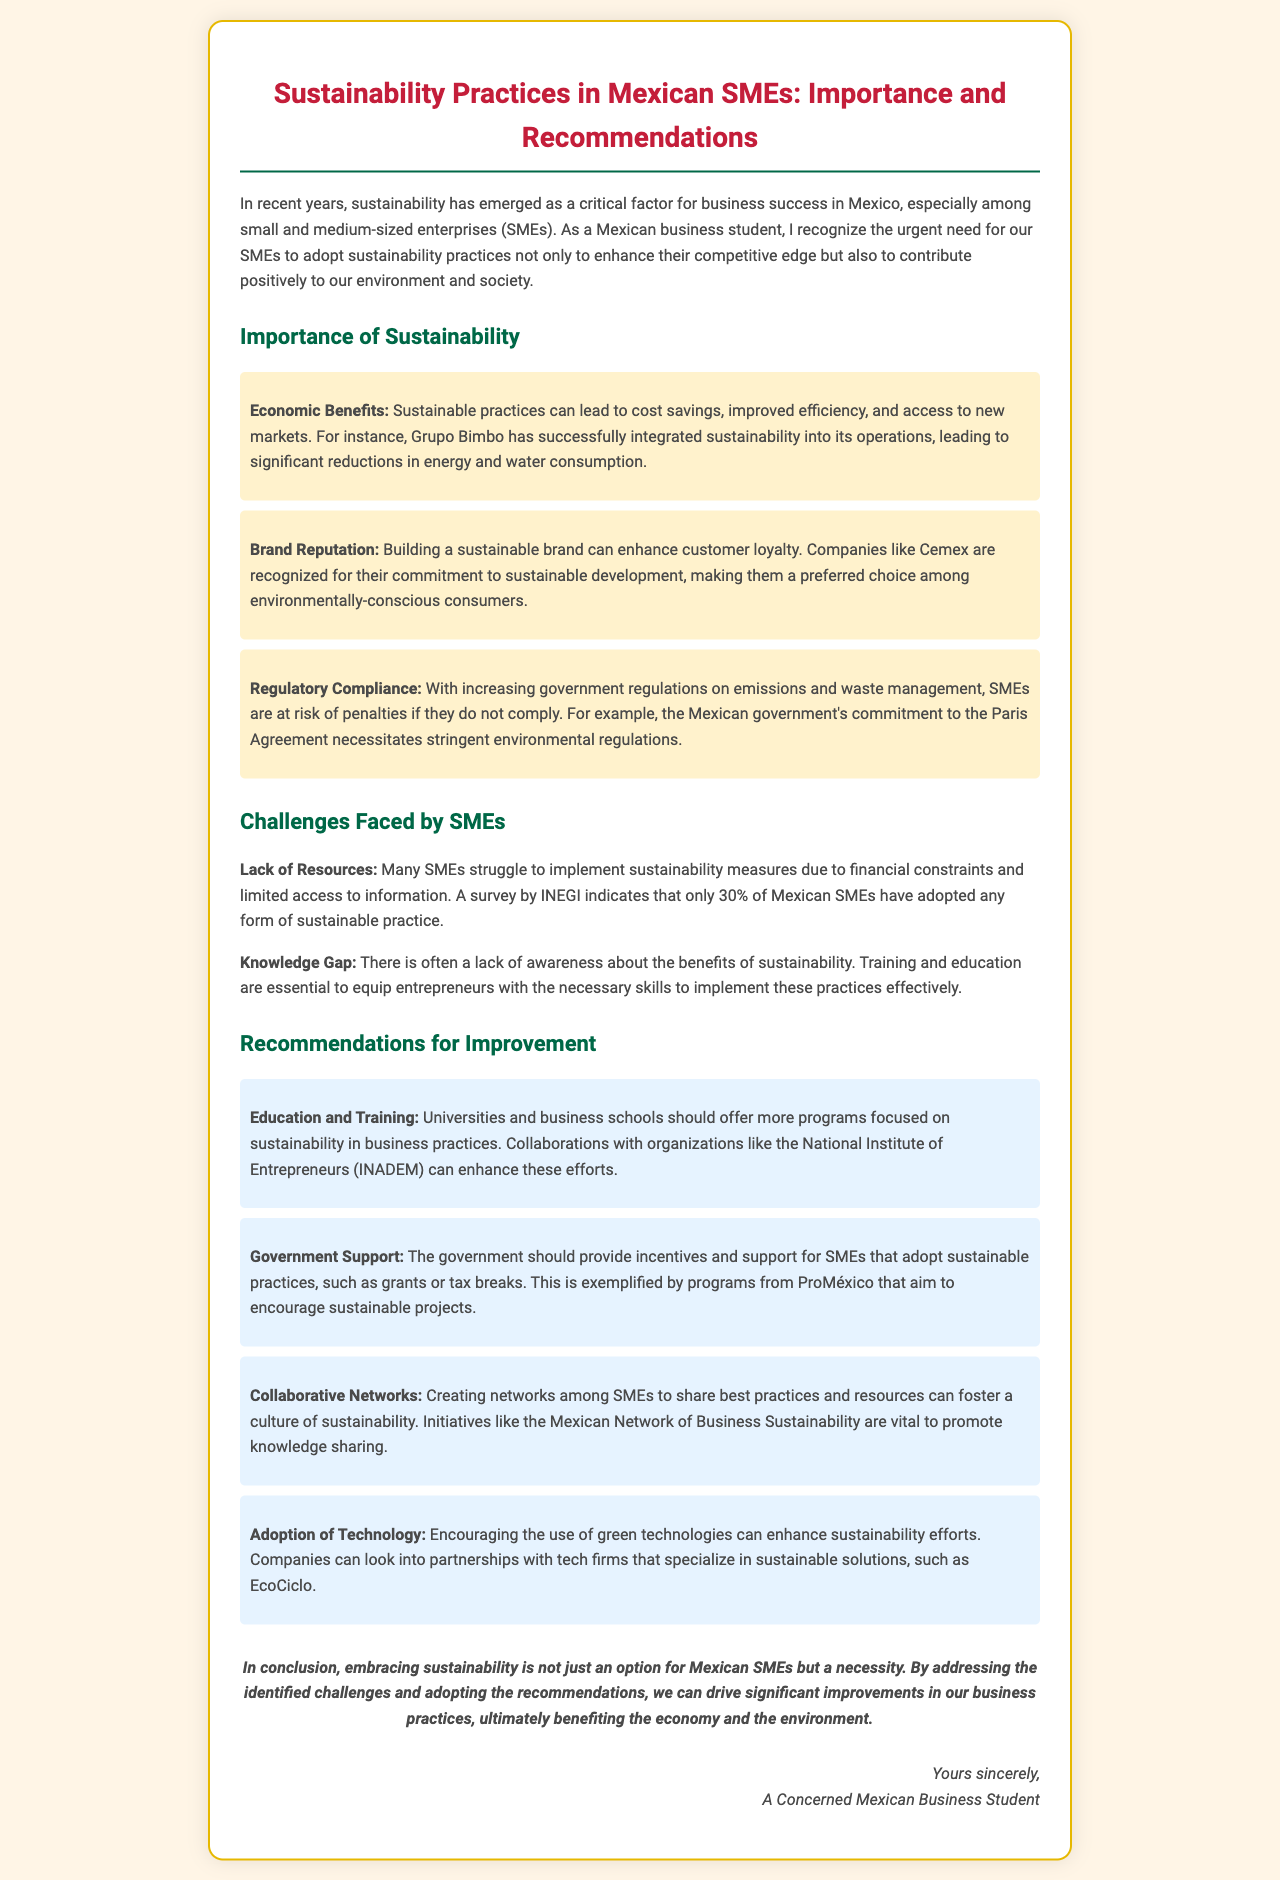What is the main topic of the letter? The main topic discussed in the letter is the importance of sustainability practices among Mexican SMEs and recommendations for improvement.
Answer: Sustainability practices in Mexican SMEs What percentage of Mexican SMEs have adopted any form of sustainable practice? The document states that only 30% of Mexican SMEs have adopted any form of sustainable practice.
Answer: 30% Which company is mentioned as successfully integrating sustainability into its operations? Grupo Bimbo is highlighted in the letter for successfully integrating sustainability into its operations.
Answer: Grupo Bimbo What is one key challenge faced by SMEs regarding sustainability? The letter identifies a lack of resources as one of the key challenges faced by SMEs in implementing sustainability measures.
Answer: Lack of resources What type of support should the government provide to encourage sustainability? The document suggests that the government should provide incentives and support such as grants or tax breaks to encourage sustainability among SMEs.
Answer: Incentives and support Which organization is mentioned as a potential collaborator for universities to enhance sustainability efforts? The National Institute of Entrepreneurs (INADEM) is mentioned as a potential collaborator in this context.
Answer: INADEM What is a recommended strategy for SMEs to enhance sustainability practices? One recommendation is to create collaborative networks among SMEs to share best practices and resources.
Answer: Collaborative networks What is a potential benefit of sustainable practices according to the document? A potential benefit listed is improved efficiency, which can lead to cost savings and access to new markets.
Answer: Improved efficiency What is the concluding sentiment of the letter? The conclusion emphasizes that embracing sustainability is a necessity for Mexican SMEs to drive improvements in business practices.
Answer: Necessity to embrace sustainability 